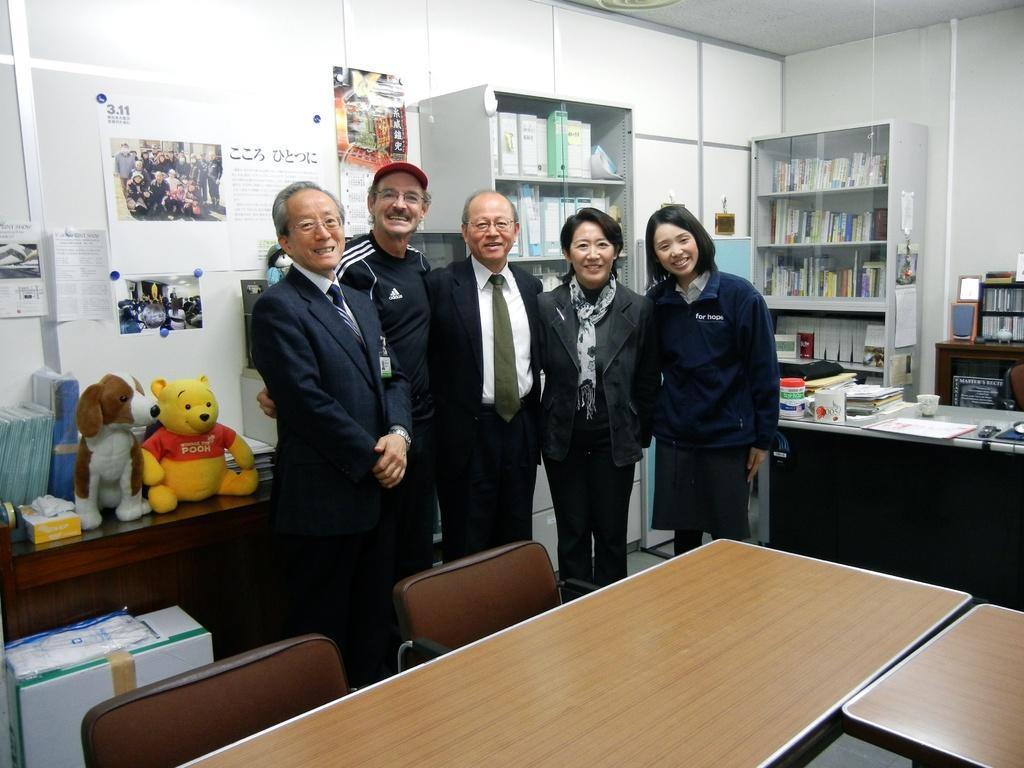In one or two sentences, can you explain what this image depicts? In this image there are five person standing. There is a table and a chair. On the table there is a cup,books. There is a book rack. 